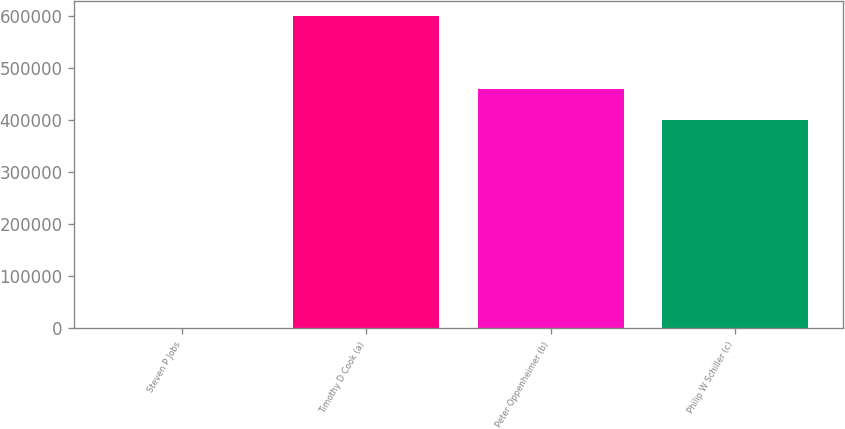Convert chart. <chart><loc_0><loc_0><loc_500><loc_500><bar_chart><fcel>Steven P Jobs<fcel>Timothy D Cook (a)<fcel>Peter Oppenheimer (b)<fcel>Philip W Schiller (c)<nl><fcel>5<fcel>600000<fcel>460000<fcel>400000<nl></chart> 